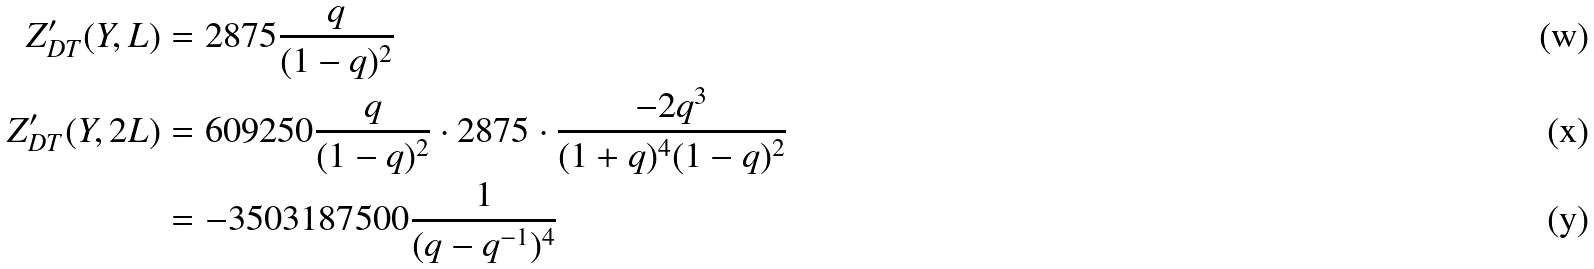<formula> <loc_0><loc_0><loc_500><loc_500>Z ^ { \prime } _ { D T } ( Y , L ) & = 2 8 7 5 \frac { q } { ( 1 - q ) ^ { 2 } } \\ Z ^ { \prime } _ { D T } ( Y , 2 L ) & = 6 0 9 2 5 0 \frac { q } { ( 1 - q ) ^ { 2 } } \cdot 2 8 7 5 \cdot \frac { - 2 q ^ { 3 } } { ( 1 + q ) ^ { 4 } ( 1 - q ) ^ { 2 } } \\ & = - 3 5 0 3 1 8 7 5 0 0 \frac { 1 } { ( q - q ^ { - 1 } ) ^ { 4 } }</formula> 